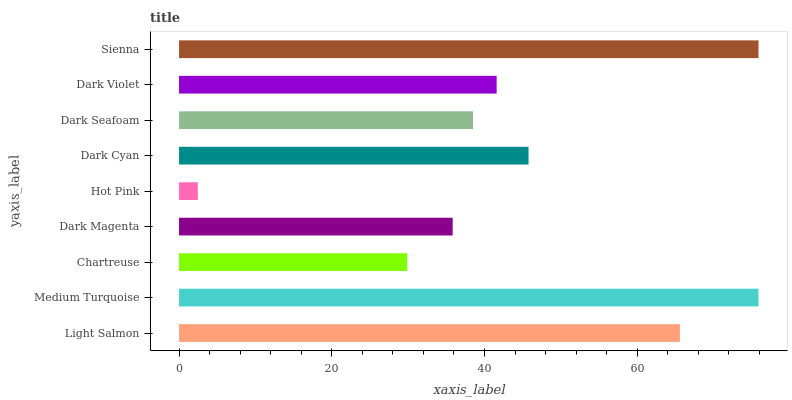Is Hot Pink the minimum?
Answer yes or no. Yes. Is Sienna the maximum?
Answer yes or no. Yes. Is Medium Turquoise the minimum?
Answer yes or no. No. Is Medium Turquoise the maximum?
Answer yes or no. No. Is Medium Turquoise greater than Light Salmon?
Answer yes or no. Yes. Is Light Salmon less than Medium Turquoise?
Answer yes or no. Yes. Is Light Salmon greater than Medium Turquoise?
Answer yes or no. No. Is Medium Turquoise less than Light Salmon?
Answer yes or no. No. Is Dark Violet the high median?
Answer yes or no. Yes. Is Dark Violet the low median?
Answer yes or no. Yes. Is Sienna the high median?
Answer yes or no. No. Is Dark Seafoam the low median?
Answer yes or no. No. 